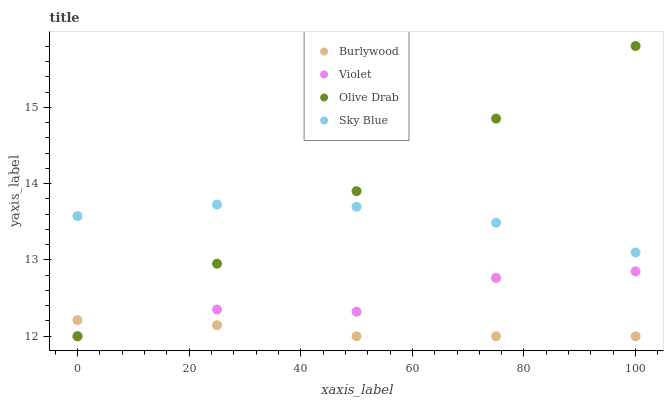Does Burlywood have the minimum area under the curve?
Answer yes or no. Yes. Does Olive Drab have the maximum area under the curve?
Answer yes or no. Yes. Does Sky Blue have the minimum area under the curve?
Answer yes or no. No. Does Sky Blue have the maximum area under the curve?
Answer yes or no. No. Is Olive Drab the smoothest?
Answer yes or no. Yes. Is Violet the roughest?
Answer yes or no. Yes. Is Sky Blue the smoothest?
Answer yes or no. No. Is Sky Blue the roughest?
Answer yes or no. No. Does Burlywood have the lowest value?
Answer yes or no. Yes. Does Sky Blue have the lowest value?
Answer yes or no. No. Does Olive Drab have the highest value?
Answer yes or no. Yes. Does Sky Blue have the highest value?
Answer yes or no. No. Is Violet less than Sky Blue?
Answer yes or no. Yes. Is Sky Blue greater than Violet?
Answer yes or no. Yes. Does Violet intersect Olive Drab?
Answer yes or no. Yes. Is Violet less than Olive Drab?
Answer yes or no. No. Is Violet greater than Olive Drab?
Answer yes or no. No. Does Violet intersect Sky Blue?
Answer yes or no. No. 